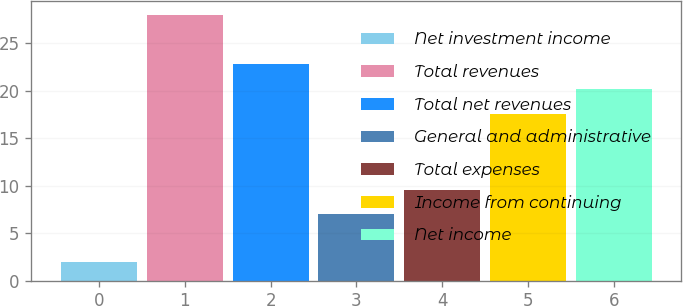<chart> <loc_0><loc_0><loc_500><loc_500><bar_chart><fcel>Net investment income<fcel>Total revenues<fcel>Total net revenues<fcel>General and administrative<fcel>Total expenses<fcel>Income from continuing<fcel>Net income<nl><fcel>2<fcel>28<fcel>22.8<fcel>7<fcel>9.6<fcel>17.6<fcel>20.2<nl></chart> 